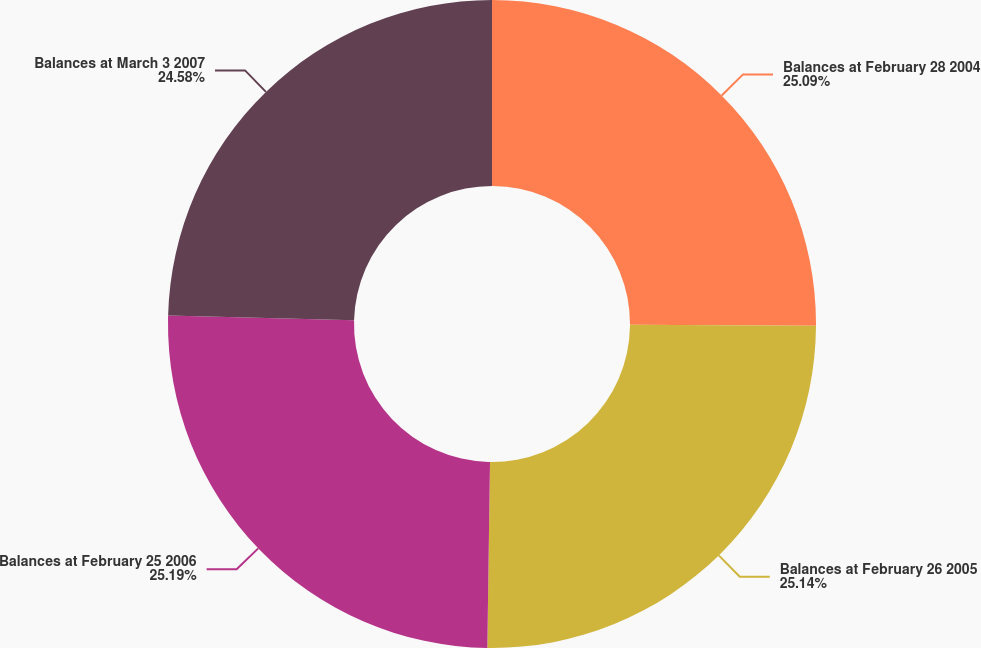<chart> <loc_0><loc_0><loc_500><loc_500><pie_chart><fcel>Balances at February 28 2004<fcel>Balances at February 26 2005<fcel>Balances at February 25 2006<fcel>Balances at March 3 2007<nl><fcel>25.09%<fcel>25.14%<fcel>25.19%<fcel>24.58%<nl></chart> 